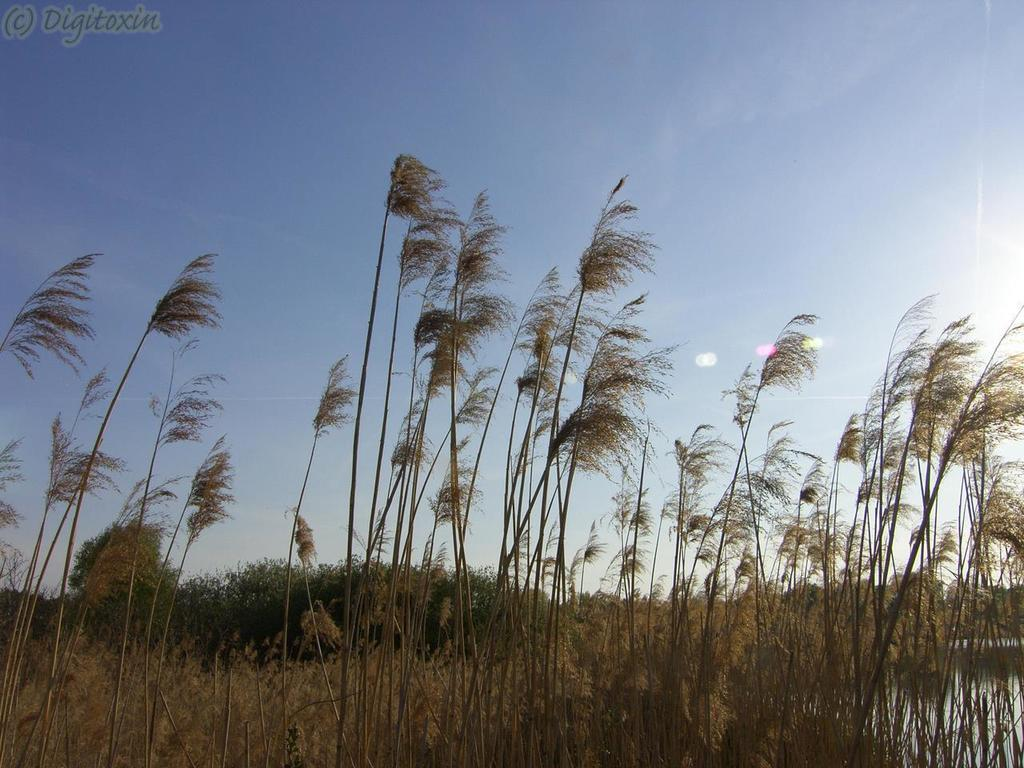What type of vegetation can be seen in the image? There are plants and grass visible in the image. What natural element is present in the image? There is water visible in the image. What is the color of the sky in the image? The sky is pale blue in the image. Is there any text or marking in the image? Yes, there is a watermark in the top left corner of the image. What grade does the deer receive for its performance in the image? There is no deer present in the image, so it cannot receive a grade for its performance. What type of material is the canvas used for the image? The image is not on a canvas; it is a digital image with a watermark. 